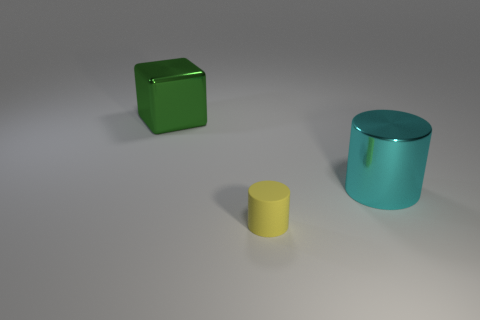What number of small things are green objects or yellow matte cubes?
Your answer should be very brief. 0. Do the big metal cylinder and the matte thing have the same color?
Make the answer very short. No. Are there more small cylinders that are behind the yellow rubber cylinder than small cylinders left of the large green block?
Provide a short and direct response. No. There is a cylinder in front of the big cyan object; is it the same color as the block?
Give a very brief answer. No. Is there anything else that is the same color as the cube?
Give a very brief answer. No. Are there more cylinders that are behind the large cyan object than red matte cylinders?
Keep it short and to the point. No. Do the cube and the cyan object have the same size?
Provide a succinct answer. Yes. There is another big object that is the same shape as the yellow rubber thing; what material is it?
Your response must be concise. Metal. Is there anything else that has the same material as the tiny object?
Offer a very short reply. No. How many cyan objects are either small blocks or cylinders?
Keep it short and to the point. 1. 